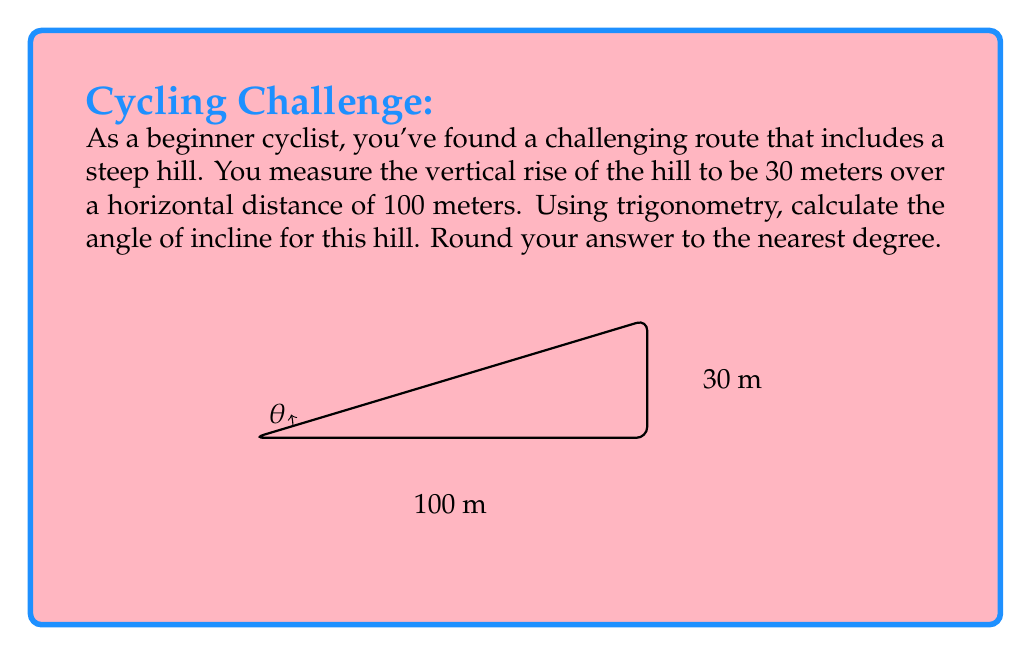Can you answer this question? To solve this problem, we'll use the tangent function from trigonometry. The tangent of an angle in a right triangle is the ratio of the opposite side to the adjacent side.

1) In this case, we have:
   - Opposite side (vertical rise) = 30 meters
   - Adjacent side (horizontal distance) = 100 meters

2) The tangent of the angle $\theta$ is:

   $$\tan(\theta) = \frac{\text{opposite}}{\text{adjacent}} = \frac{30}{100} = 0.3$$

3) To find the angle, we need to use the inverse tangent (arctan or $\tan^{-1}$):

   $$\theta = \tan^{-1}(0.3)$$

4) Using a calculator or trigonometric tables:

   $$\theta \approx 16.70^\circ$$

5) Rounding to the nearest degree:

   $$\theta \approx 17^\circ$$

This means the hill has an incline angle of approximately 17 degrees.
Answer: $17^\circ$ 